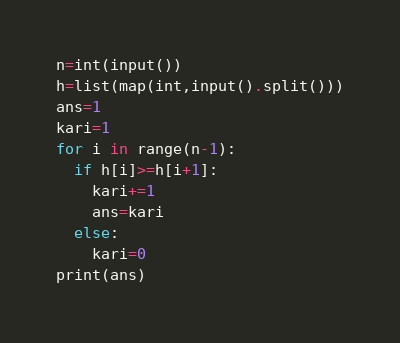Convert code to text. <code><loc_0><loc_0><loc_500><loc_500><_Python_>n=int(input())
h=list(map(int,input().split()))
ans=1
kari=1
for i in range(n-1):
  if h[i]>=h[i+1]:
    kari+=1
    ans=kari
  else:
    kari=0
print(ans)</code> 